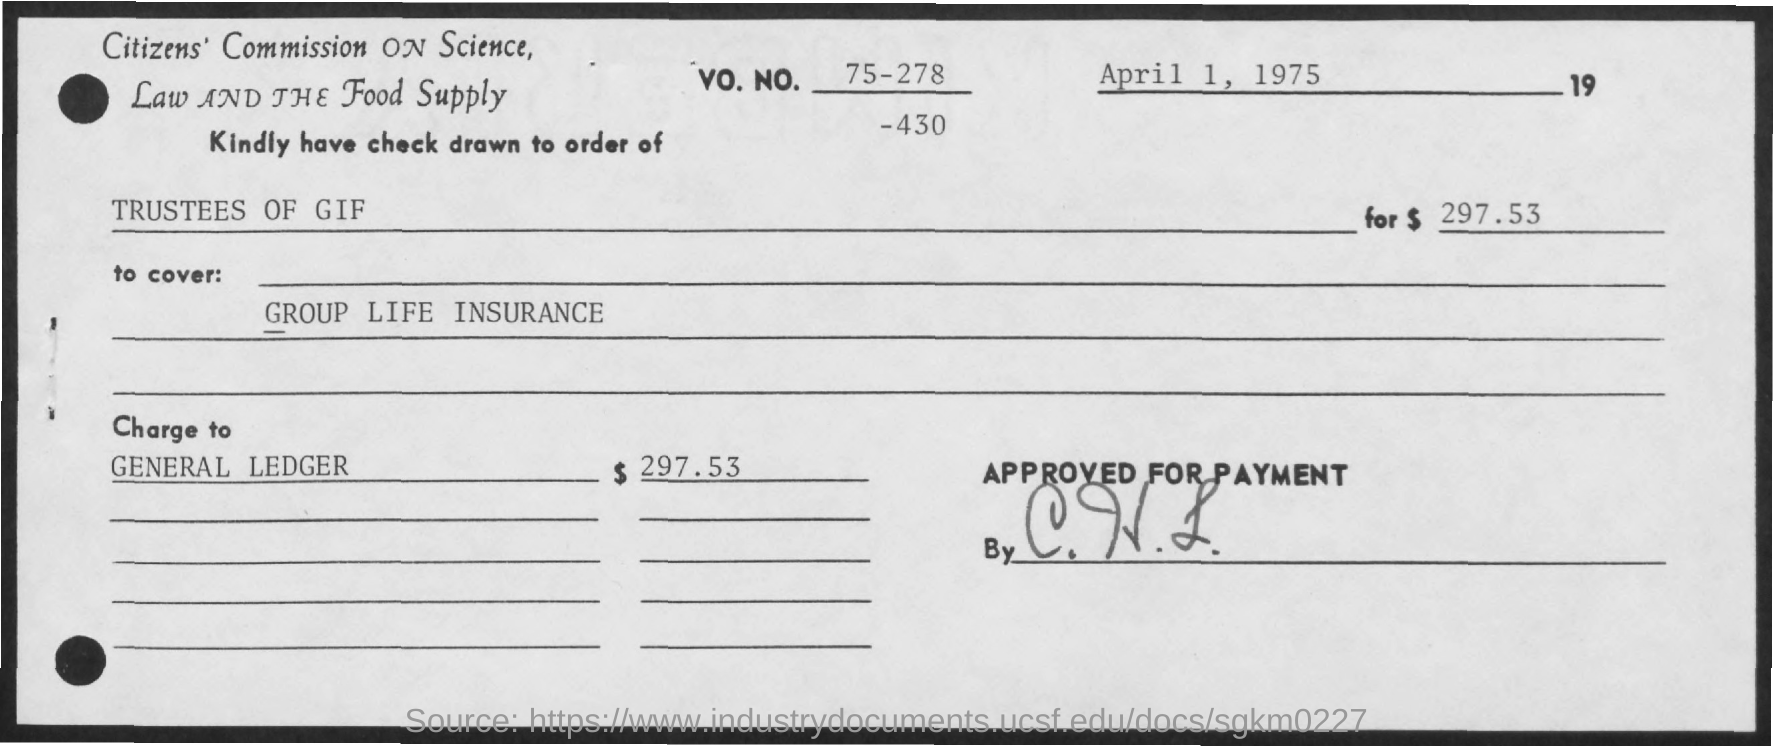Mention a couple of crucial points in this snapshot. The document is dated April 1, 1975. The amount is $297.53. 